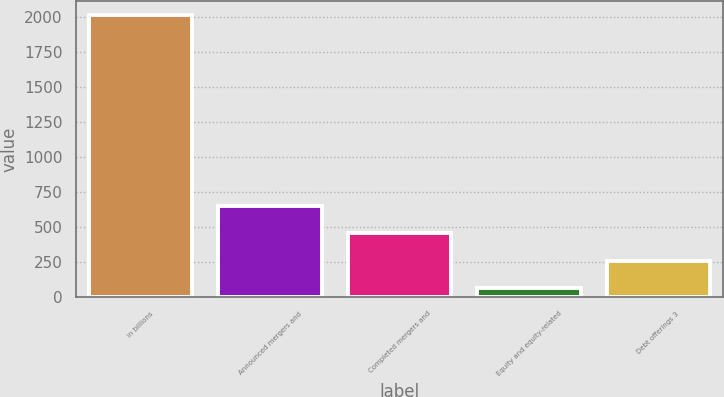Convert chart. <chart><loc_0><loc_0><loc_500><loc_500><bar_chart><fcel>in billions<fcel>Announced mergers and<fcel>Completed mergers and<fcel>Equity and equity-related<fcel>Debt offerings 3<nl><fcel>2010<fcel>649.9<fcel>455.6<fcel>67<fcel>261.3<nl></chart> 